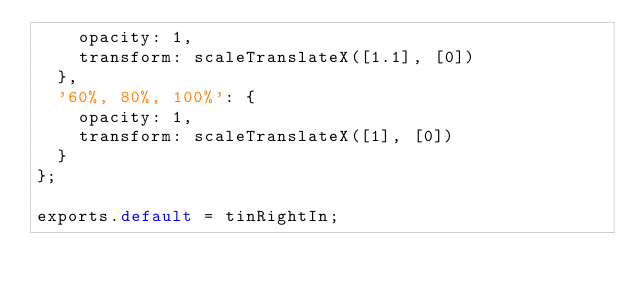Convert code to text. <code><loc_0><loc_0><loc_500><loc_500><_JavaScript_>    opacity: 1,
    transform: scaleTranslateX([1.1], [0])
  },
  '60%, 80%, 100%': {
    opacity: 1,
    transform: scaleTranslateX([1], [0])
  }
};

exports.default = tinRightIn;</code> 